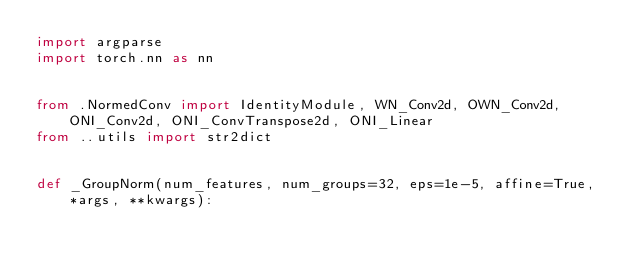Convert code to text. <code><loc_0><loc_0><loc_500><loc_500><_Python_>import argparse
import torch.nn as nn


from .NormedConv import IdentityModule, WN_Conv2d, OWN_Conv2d, ONI_Conv2d, ONI_ConvTranspose2d, ONI_Linear
from ..utils import str2dict


def _GroupNorm(num_features, num_groups=32, eps=1e-5, affine=True, *args, **kwargs):</code> 